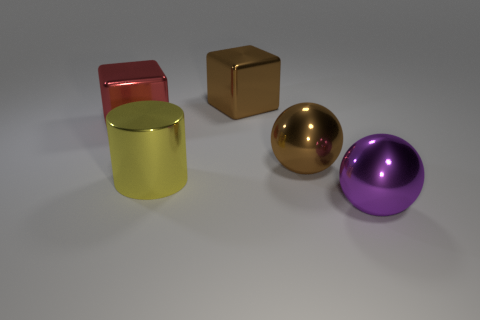Add 5 red shiny cubes. How many objects exist? 10 Subtract all cubes. How many objects are left? 3 Subtract all brown shiny balls. Subtract all big purple metallic spheres. How many objects are left? 3 Add 2 red shiny blocks. How many red shiny blocks are left? 3 Add 3 yellow cylinders. How many yellow cylinders exist? 4 Subtract 0 green spheres. How many objects are left? 5 